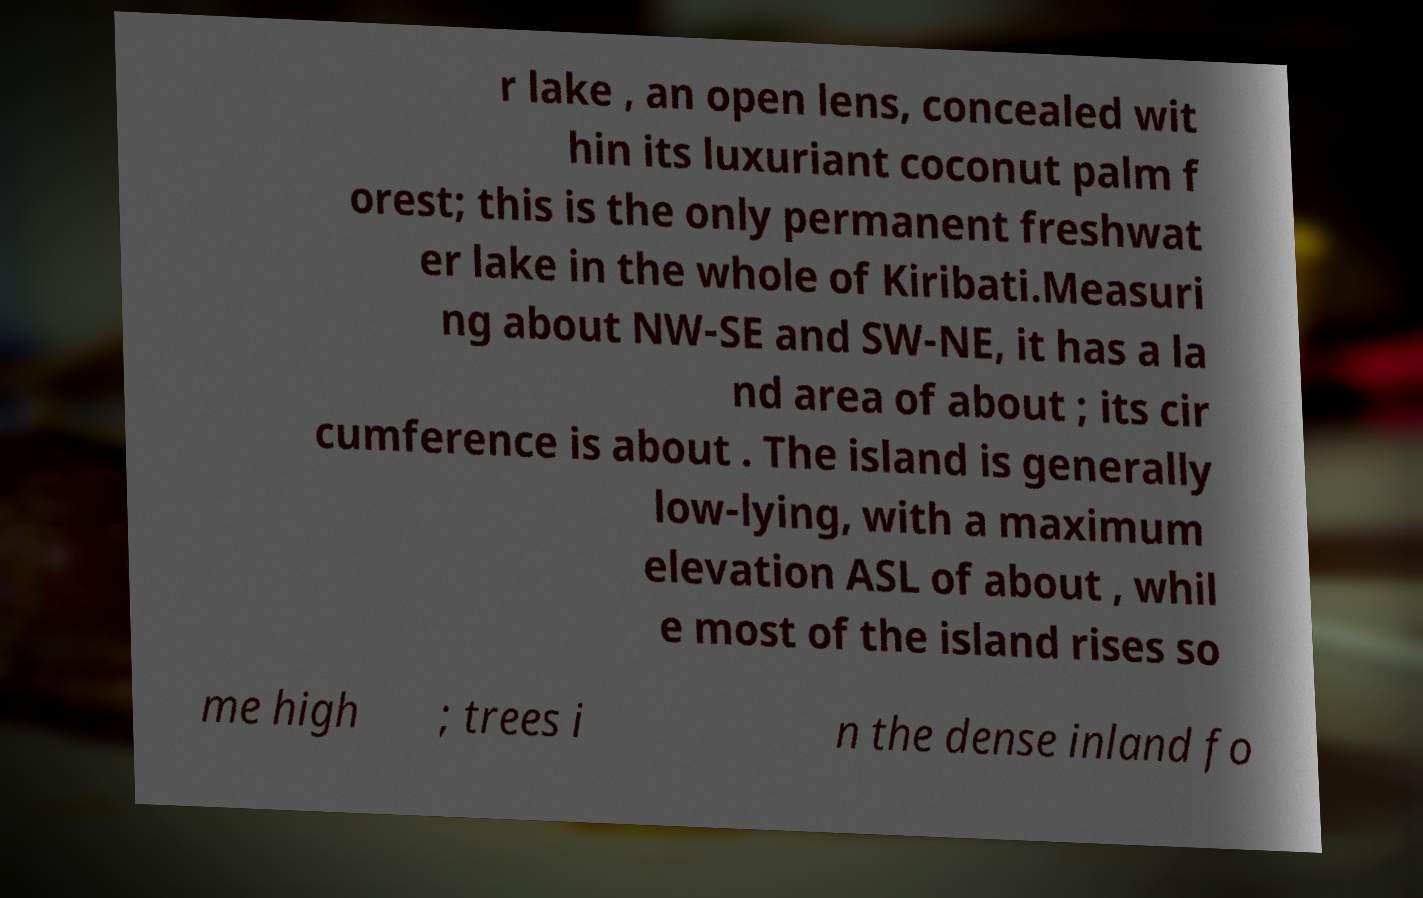I need the written content from this picture converted into text. Can you do that? r lake , an open lens, concealed wit hin its luxuriant coconut palm f orest; this is the only permanent freshwat er lake in the whole of Kiribati.Measuri ng about NW-SE and SW-NE, it has a la nd area of about ; its cir cumference is about . The island is generally low-lying, with a maximum elevation ASL of about , whil e most of the island rises so me high ; trees i n the dense inland fo 